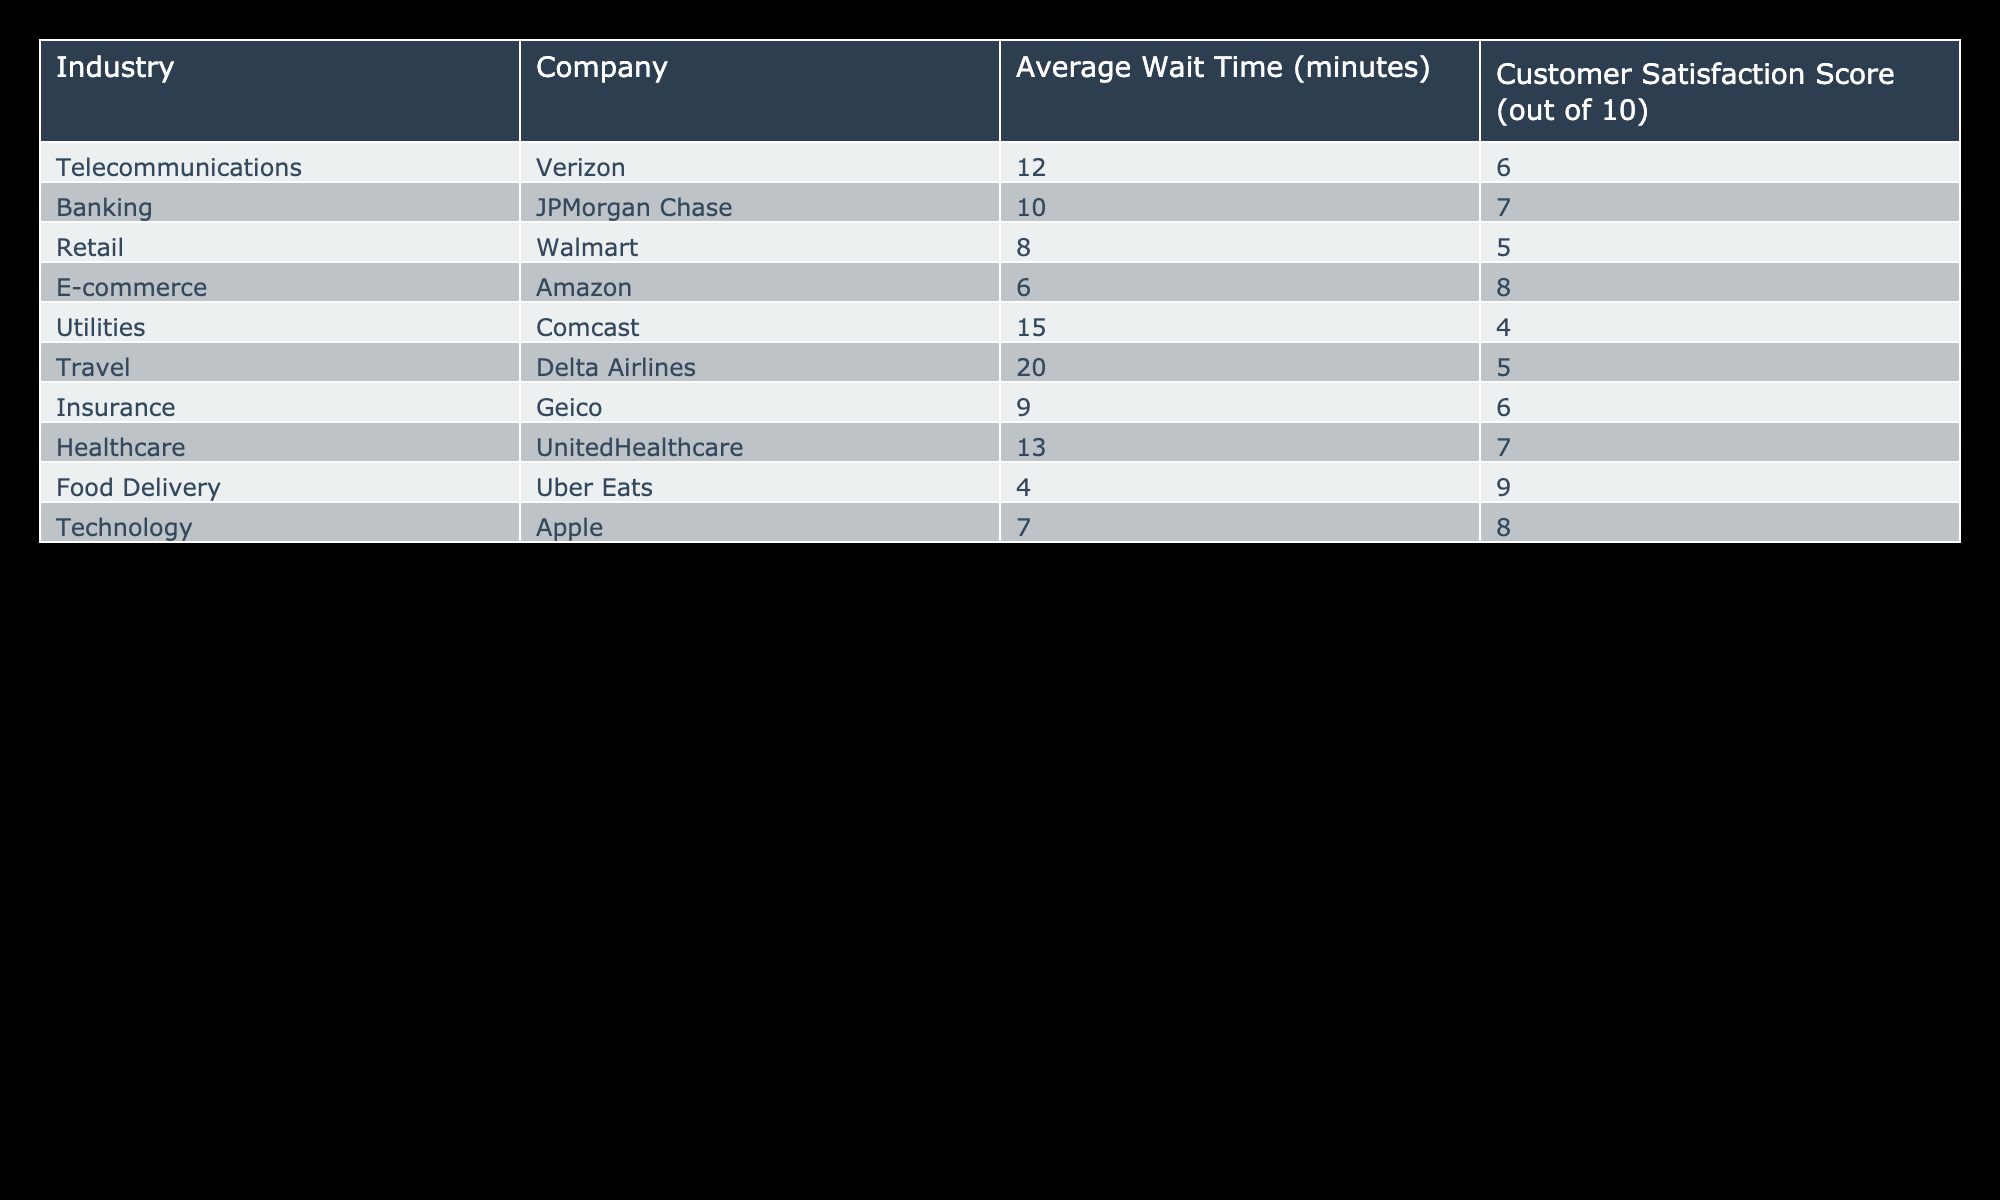What is the average wait time for the Telecommunications industry? The table lists the average wait time for Verizon in the Telecommunications industry, which is 12 minutes.
Answer: 12 minutes Which industry has the highest average wait time? By reviewing the data, Delta Airlines has the highest average wait time of 20 minutes.
Answer: Delta Airlines What is the customer satisfaction score of Walmart? According to the table, Walmart has a customer satisfaction score of 5 out of 10.
Answer: 5 Which two industries have an average wait time greater than 10 minutes? From the table, the industries with an average wait time greater than 10 minutes are Telecommunications (12 minutes) and Healthcare (13 minutes).
Answer: Telecommunications and Healthcare Is the average wait time for Food Delivery less than the average wait time for Retail? Food Delivery has an average wait time of 4 minutes, while Retail has 8 minutes. Since 4 is less than 8, the statement is true.
Answer: Yes What is the difference in customer satisfaction scores between E-commerce and Utilities? The customer satisfaction score for E-commerce (Amazon) is 8, and for Utilities (Comcast) is 4. The difference is 8 - 4 = 4.
Answer: 4 What is the average customer satisfaction score among all companies in the table? To find the average, sum all the satisfaction scores (6 + 7 + 5 + 8 + 4 + 5 + 6 + 7 + 9 + 8 =  65) and divide by 10, giving an average of 6.5 out of 10.
Answer: 6.5 Which company has the second lowest average wait time? The table shows that the average wait times are 4 for Uber Eats and 6 for Amazon. Therefore, Amazon has the second lowest wait time.
Answer: Amazon Are insurance companies generally quicker in terms of wait times compared to banking companies? Geico (insurance) has a wait time of 9 minutes and JPMorgan Chase (banking) has a wait time of 10 minutes. Since 9 is less than 10, insurance companies are indeed quicker.
Answer: Yes 